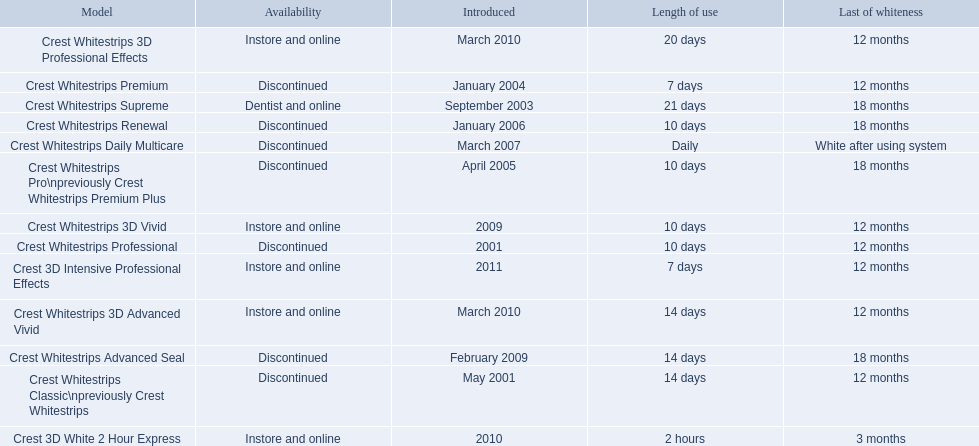Could you parse the entire table as a dict? {'header': ['Model', 'Availability', 'Introduced', 'Length of use', 'Last of whiteness'], 'rows': [['Crest Whitestrips 3D Professional Effects', 'Instore and online', 'March 2010', '20 days', '12 months'], ['Crest Whitestrips Premium', 'Discontinued', 'January 2004', '7 days', '12 months'], ['Crest Whitestrips Supreme', 'Dentist and online', 'September 2003', '21 days', '18 months'], ['Crest Whitestrips Renewal', 'Discontinued', 'January 2006', '10 days', '18 months'], ['Crest Whitestrips Daily Multicare', 'Discontinued', 'March 2007', 'Daily', 'White after using system'], ['Crest Whitestrips Pro\\npreviously Crest Whitestrips Premium Plus', 'Discontinued', 'April 2005', '10 days', '18 months'], ['Crest Whitestrips 3D Vivid', 'Instore and online', '2009', '10 days', '12 months'], ['Crest Whitestrips Professional', 'Discontinued', '2001', '10 days', '12 months'], ['Crest 3D Intensive Professional Effects', 'Instore and online', '2011', '7 days', '12 months'], ['Crest Whitestrips 3D Advanced Vivid', 'Instore and online', 'March 2010', '14 days', '12 months'], ['Crest Whitestrips Advanced Seal', 'Discontinued', 'February 2009', '14 days', '18 months'], ['Crest Whitestrips Classic\\npreviously Crest Whitestrips', 'Discontinued', 'May 2001', '14 days', '12 months'], ['Crest 3D White 2 Hour Express', 'Instore and online', '2010', '2 hours', '3 months']]} What year did crest come out with crest white strips 3d vivid? 2009. Which crest product was also introduced he same year, but is now discontinued? Crest Whitestrips Advanced Seal. 